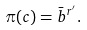<formula> <loc_0><loc_0><loc_500><loc_500>\pi ( c ) = \bar { b } ^ { r ^ { \prime } } .</formula> 